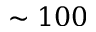Convert formula to latex. <formula><loc_0><loc_0><loc_500><loc_500>\sim 1 0 0</formula> 